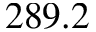<formula> <loc_0><loc_0><loc_500><loc_500>2 8 9 . 2</formula> 